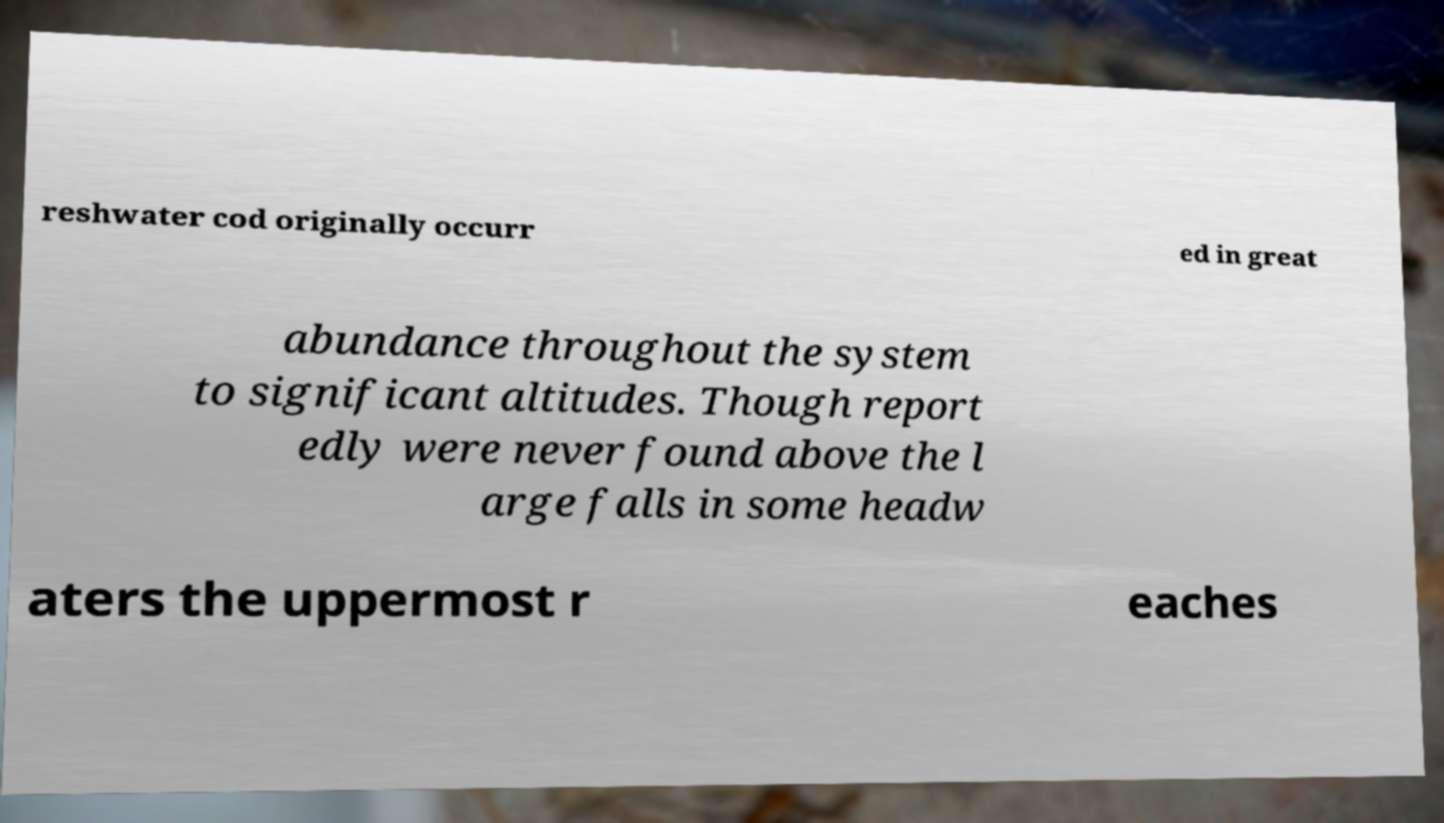Can you accurately transcribe the text from the provided image for me? reshwater cod originally occurr ed in great abundance throughout the system to significant altitudes. Though report edly were never found above the l arge falls in some headw aters the uppermost r eaches 